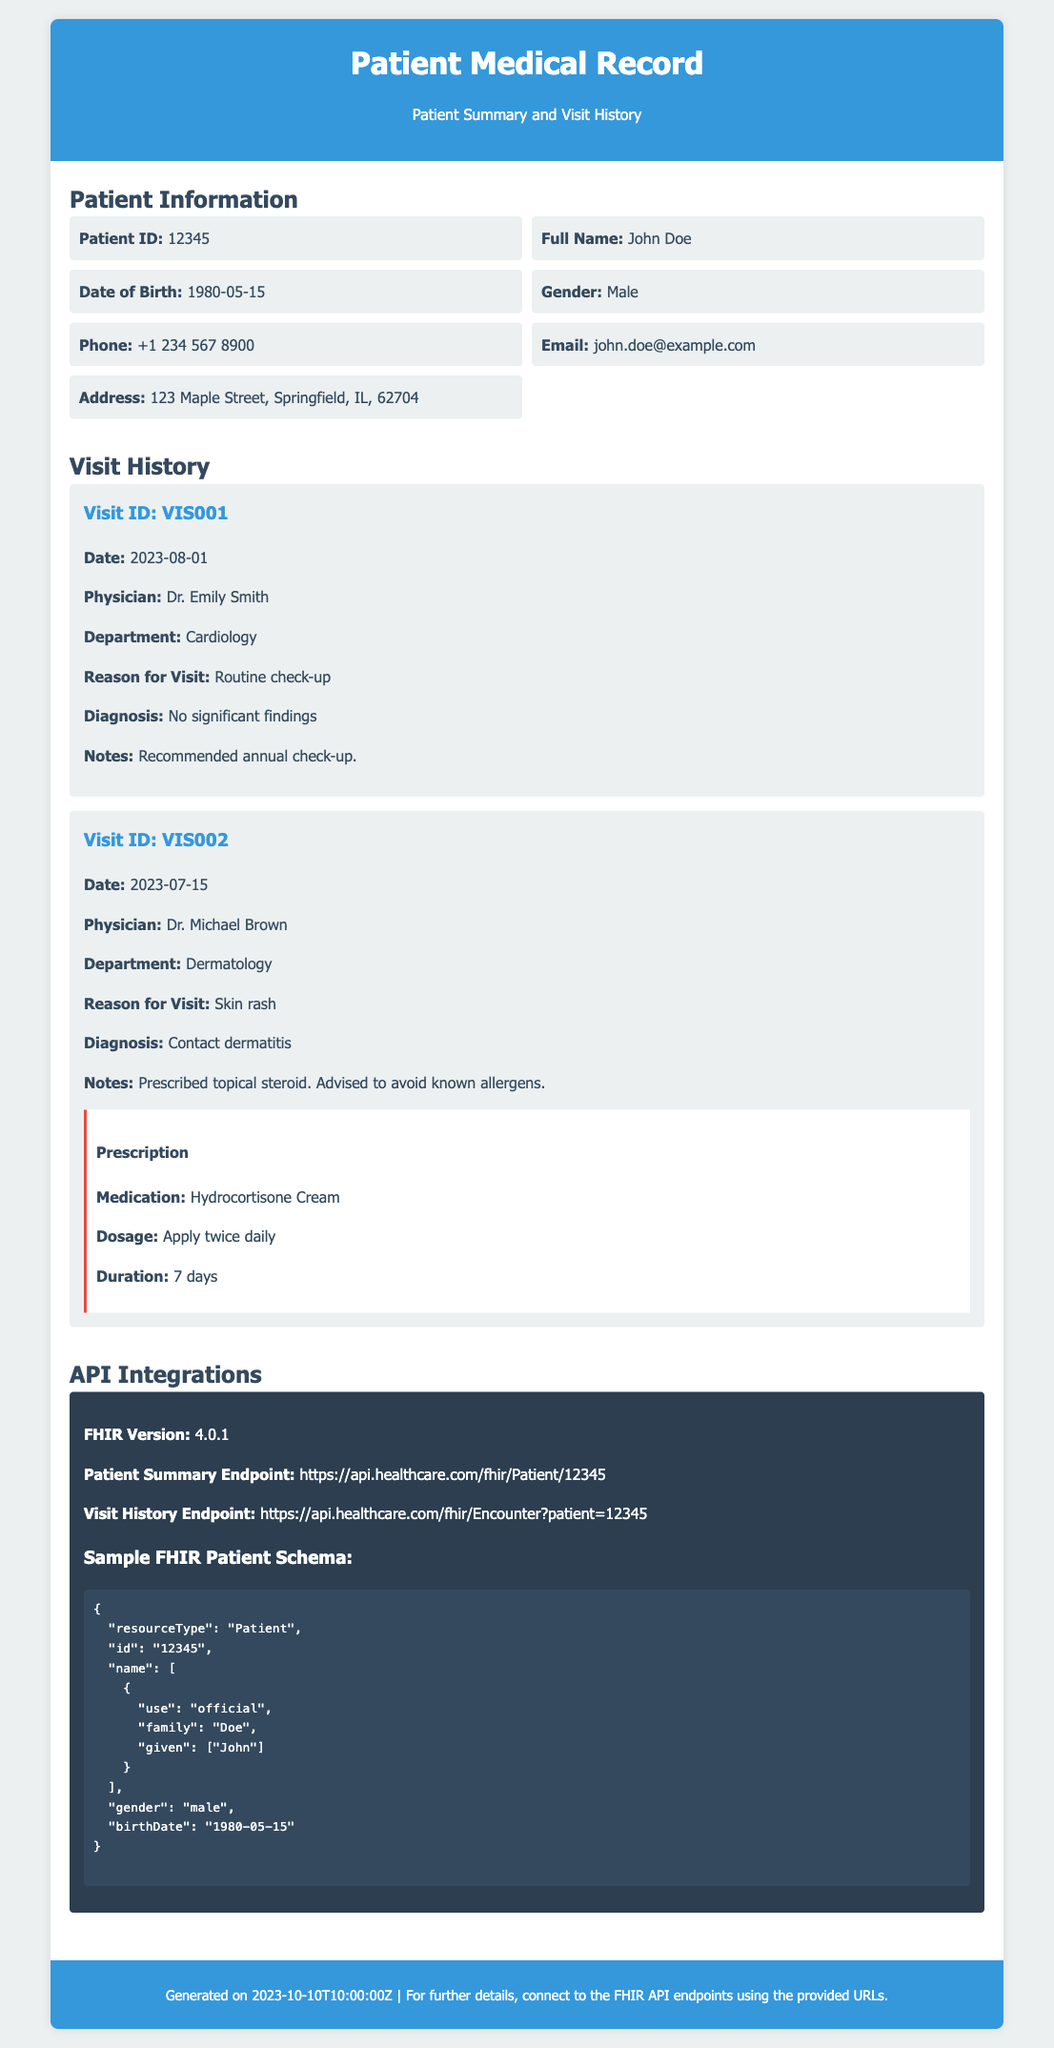What is the Patient ID? The Patient ID is explicitly mentioned in the patient information section of the document.
Answer: 12345 What is the full name of the patient? The full name of the patient is provided in the patient information section.
Answer: John Doe What is the date of birth of the patient? The date of birth can be found in the patient information section of the document.
Answer: 1980-05-15 Who is the physician for the first visit? The physician's name for the first visit can be found in the visit history section.
Answer: Dr. Emily Smith What was the reason for the second visit? The reason for the second visit is detailed in the visit history section of the document.
Answer: Skin rash What was the diagnosis for the second visit? The diagnosis for the second visit is stated in the visit history section of the document.
Answer: Contact dermatitis What is the dosage of the prescribed medication? The dosage for the prescribed medication is outlined in the prescription of the second visit.
Answer: Apply twice daily What is the FHIR version used in the API integrations? The FHIR version is mentioned in the API integrations section.
Answer: 4.0.1 What is the URL for the visit history endpoint? The URL for the visit history endpoint is available in the API integrations section.
Answer: https://api.healthcare.com/fhir/Encounter?patient=12345 What is the condition noted in the first visit? The condition noted in the first visit is summarized in the diagnosis section of the visit history.
Answer: No significant findings 